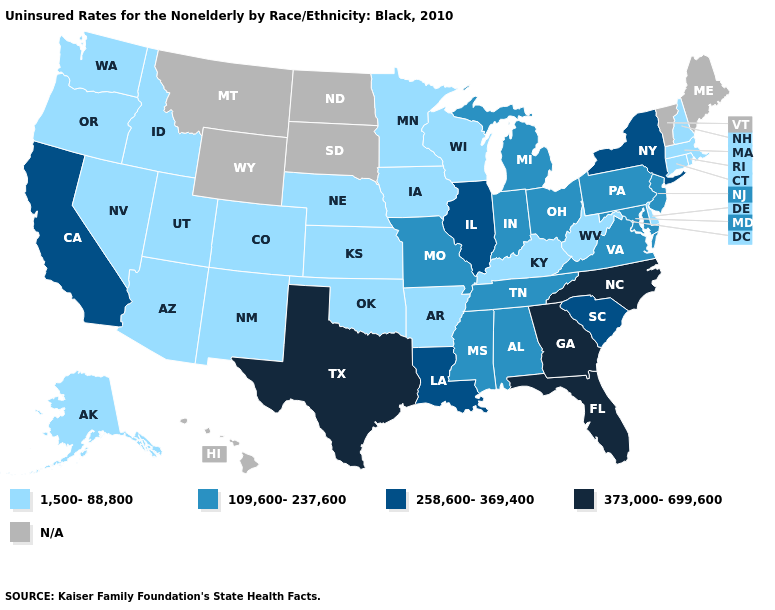What is the value of Indiana?
Answer briefly. 109,600-237,600. What is the highest value in states that border South Dakota?
Concise answer only. 1,500-88,800. What is the value of New York?
Give a very brief answer. 258,600-369,400. What is the lowest value in the USA?
Short answer required. 1,500-88,800. Does Maryland have the highest value in the USA?
Be succinct. No. Does Nevada have the lowest value in the USA?
Keep it brief. Yes. What is the value of West Virginia?
Concise answer only. 1,500-88,800. What is the value of Nevada?
Answer briefly. 1,500-88,800. Name the states that have a value in the range 258,600-369,400?
Short answer required. California, Illinois, Louisiana, New York, South Carolina. Name the states that have a value in the range N/A?
Quick response, please. Hawaii, Maine, Montana, North Dakota, South Dakota, Vermont, Wyoming. What is the value of Missouri?
Write a very short answer. 109,600-237,600. What is the lowest value in states that border New Mexico?
Short answer required. 1,500-88,800. Name the states that have a value in the range 258,600-369,400?
Quick response, please. California, Illinois, Louisiana, New York, South Carolina. What is the value of New Hampshire?
Give a very brief answer. 1,500-88,800. What is the value of South Carolina?
Quick response, please. 258,600-369,400. 